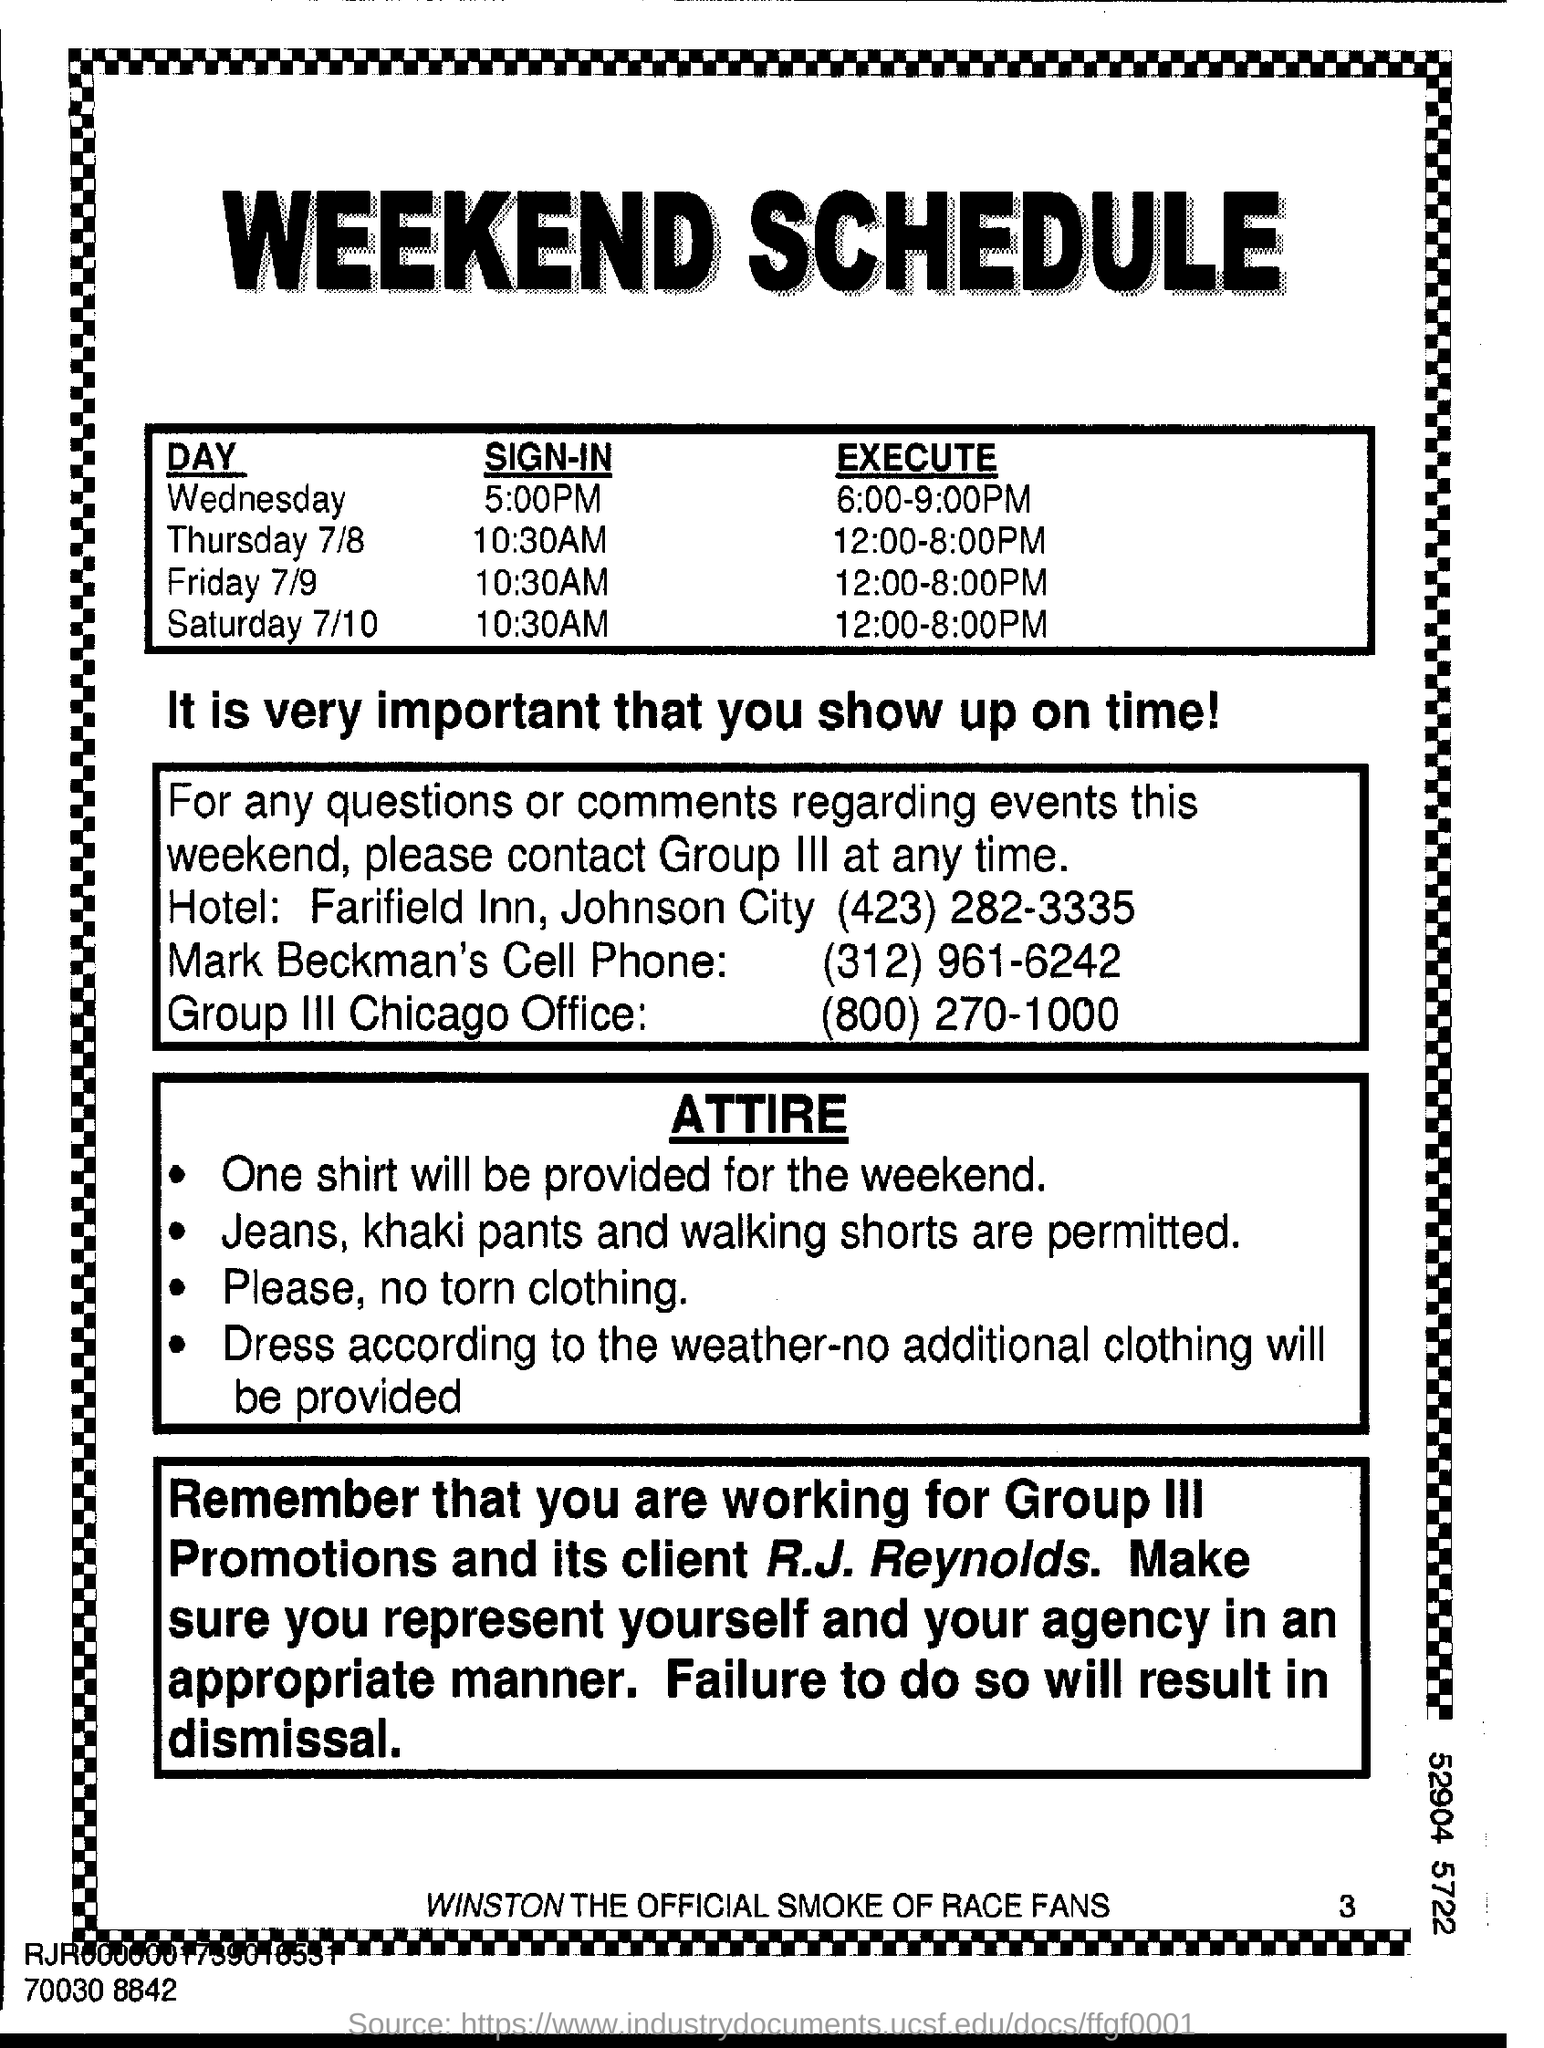Identify some key points in this picture. It is expected that one shirt will be provided for the weekend. It is prohibited to wear clothes that are torn. 